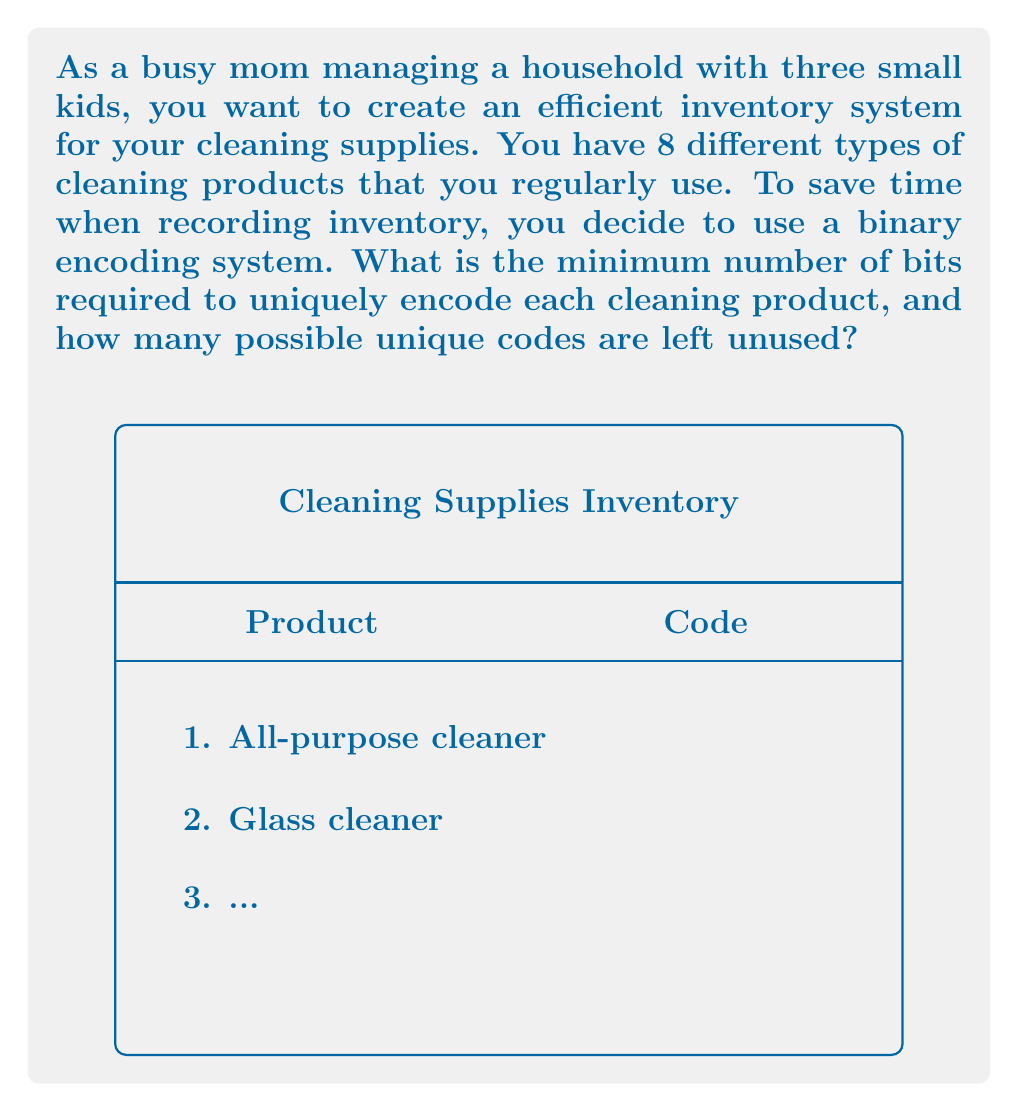Help me with this question. Let's approach this step-by-step:

1) To determine the minimum number of bits required, we need to find the smallest power of 2 that can accommodate all 8 products.

2) The formula for this is:
   $$2^n \geq 8$$
   where $n$ is the number of bits.

3) Let's solve this inequality:
   $2^3 = 8$, which is exactly enough to encode 8 products.

4) Therefore, the minimum number of bits required is 3.

5) With 3 bits, we can create $2^3 = 8$ unique codes.

6) Since we have exactly 8 products and 8 possible codes, there will be no unused codes.

7) However, if we want to calculate the number of unused codes in general:
   Unused codes = Total possible codes - Number of products
                = $2^n - 8$
                = $2^3 - 8$
                = $8 - 8$
                = $0$

This encoding system allows you to efficiently label your cleaning products with short binary codes, saving time when managing your inventory.
Answer: 3 bits; 0 unused codes 